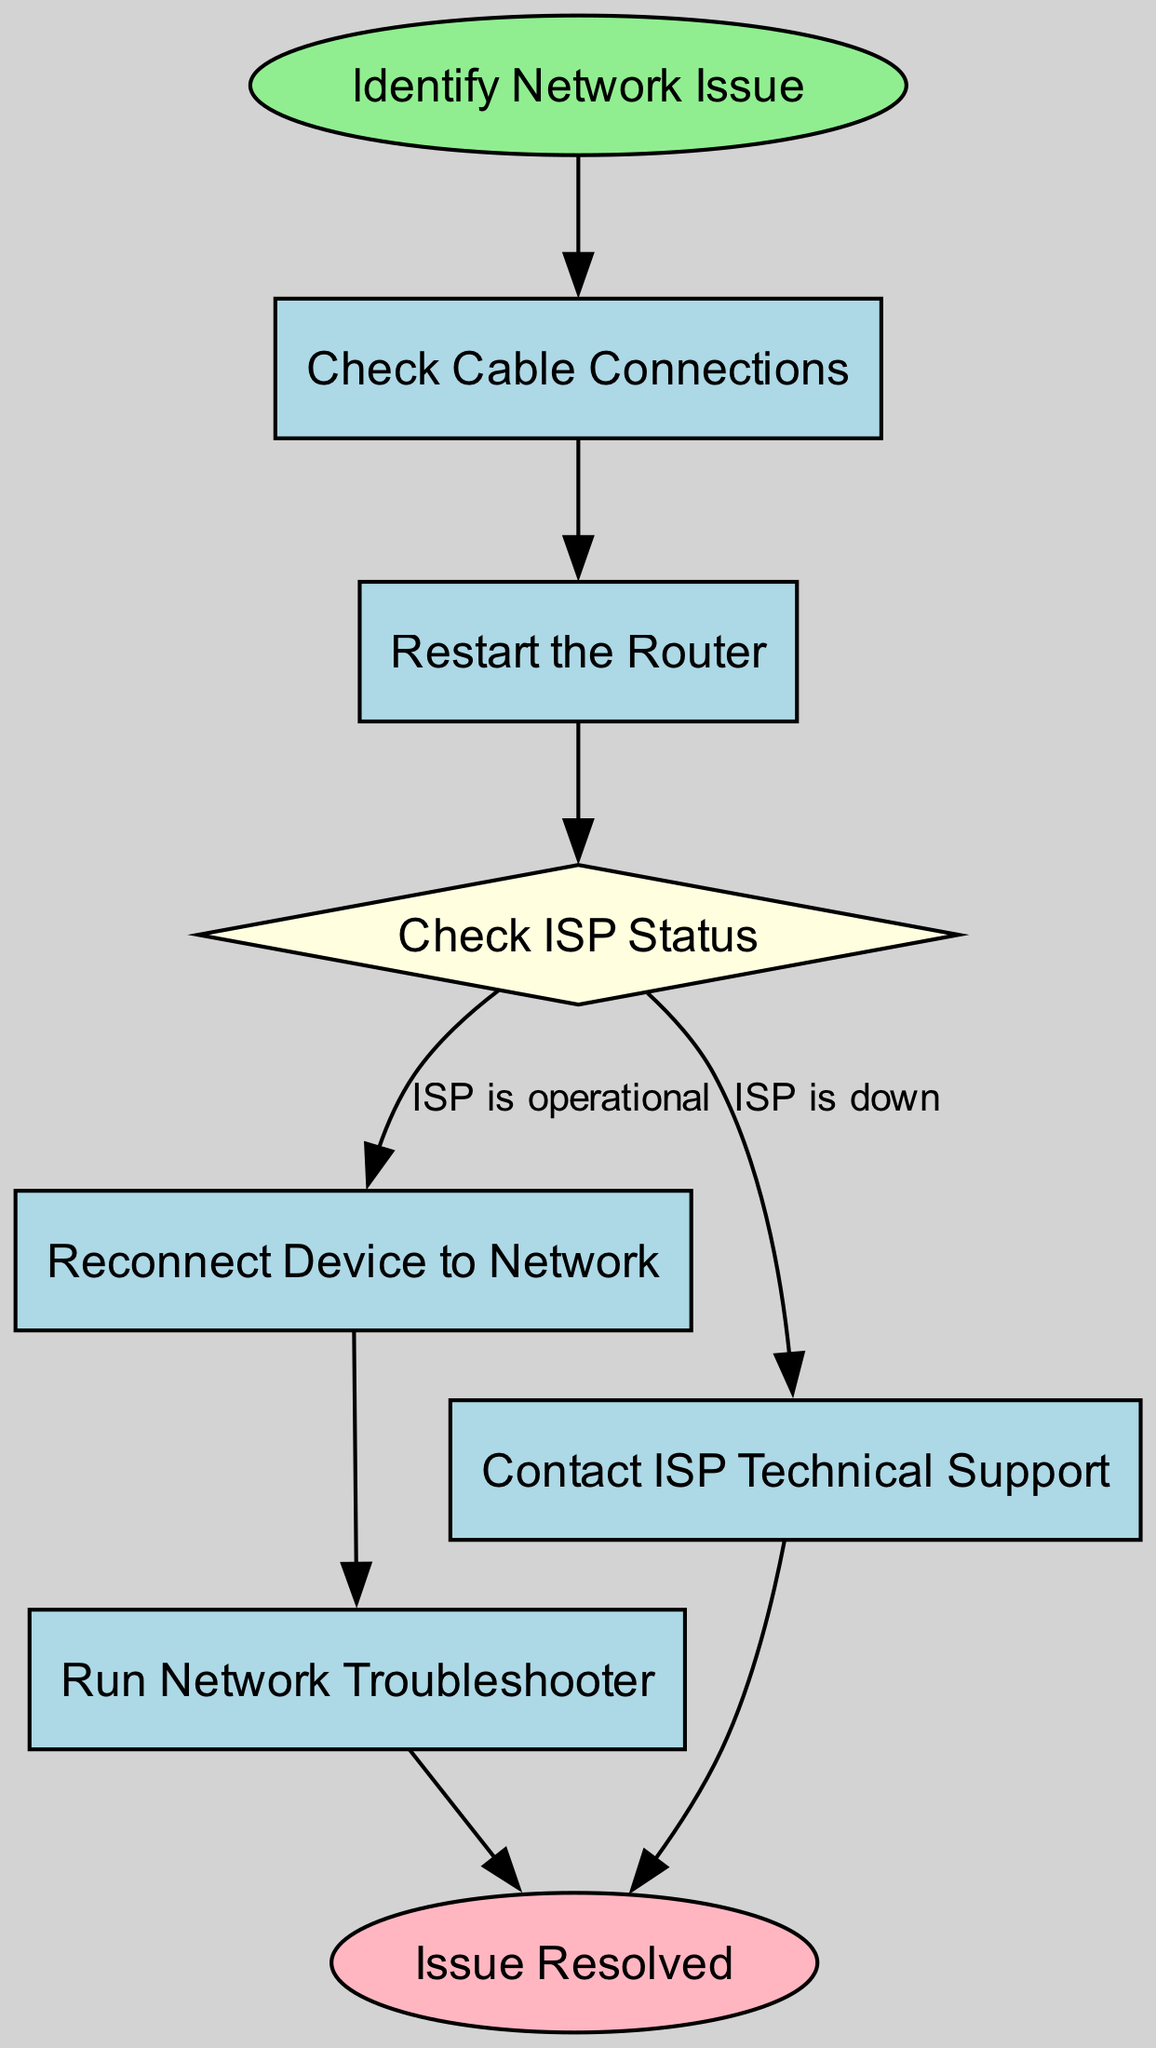What is the first step in the troubleshooting process? The first step, represented by the starting node labeled "Identify Network Issue," indicates the initial action to take when encountering network problems.
Answer: Identify Network Issue How many processes are in the flow chart? By counting the process nodes: "Check Cable Connections," "Restart the Router," "Reconnect Device to Network," "Run Network Troubleshooter," and "Contact ISP Technical Support," I find there are five process nodes total.
Answer: 5 What decision point is present in the flowchart? The decision point is labeled "Check ISP Status," where it is determined if the internet service provider is operational or down.
Answer: Check ISP Status If the ISP is down, what is the next step? If the ISP is determined to be down, the flow chart directs the user to "Contact ISP Technical Support" for assistance.
Answer: Contact ISP Technical Support What label is given to the last step in the flowchart? The final step in the flowchart is labeled "Issue Resolved," indicating that the troubleshooting process has concluded successfully.
Answer: Issue Resolved What happens after restarting the router? After restarting the router, the process chart instructs to "Check ISP Status" to verify whether the internet service is functioning.
Answer: Check ISP Status How many decision points are in the flowchart? There is one decision point in the flowchart, which is where the status of the ISP is checked to determine the next course of action.
Answer: 1 What process follows reconnecting the device to the network? After reconnecting the device to the network, the next step is to "Run Network Troubleshooter" to diagnose any remaining issues.
Answer: Run Network Troubleshooter What should you do if ISP status is operational? If the ISP status is operational, the flowchart directs to "Reconnect Device to Network" to attempt to restore connectivity.
Answer: Reconnect Device to Network 